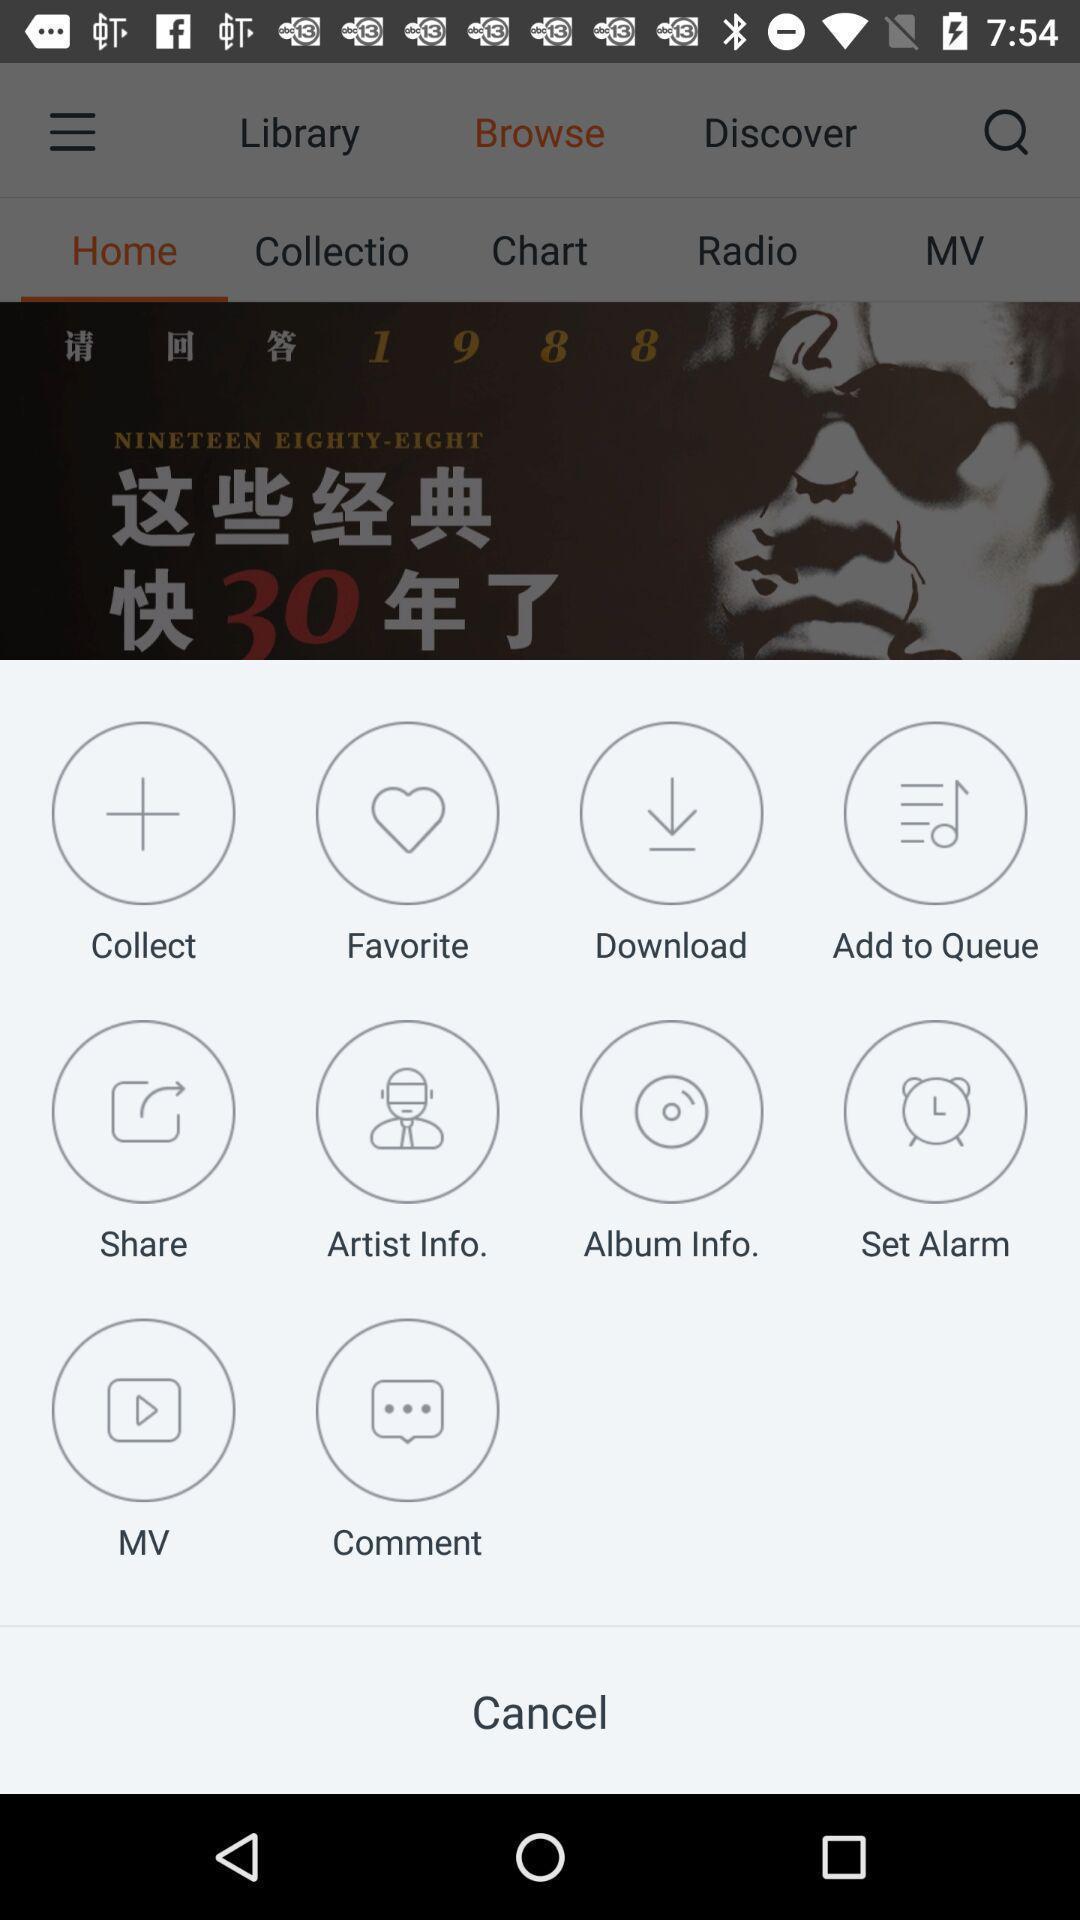Describe this image in words. Pop-up showing different icons to select. 